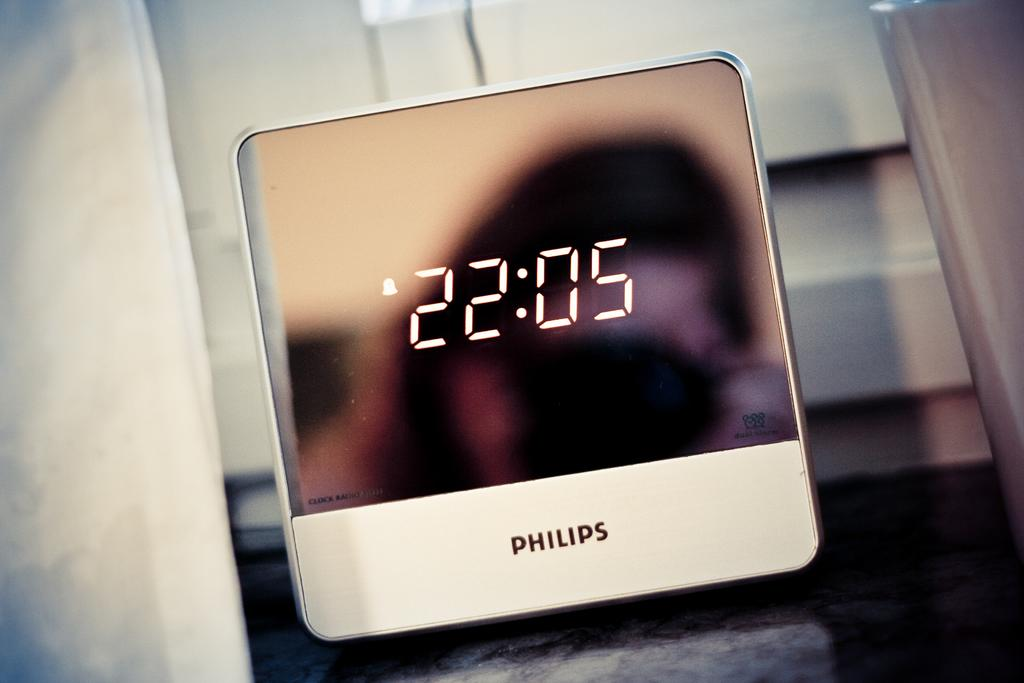<image>
Provide a brief description of the given image. A Phillips device with 22:05 on the display screen. 